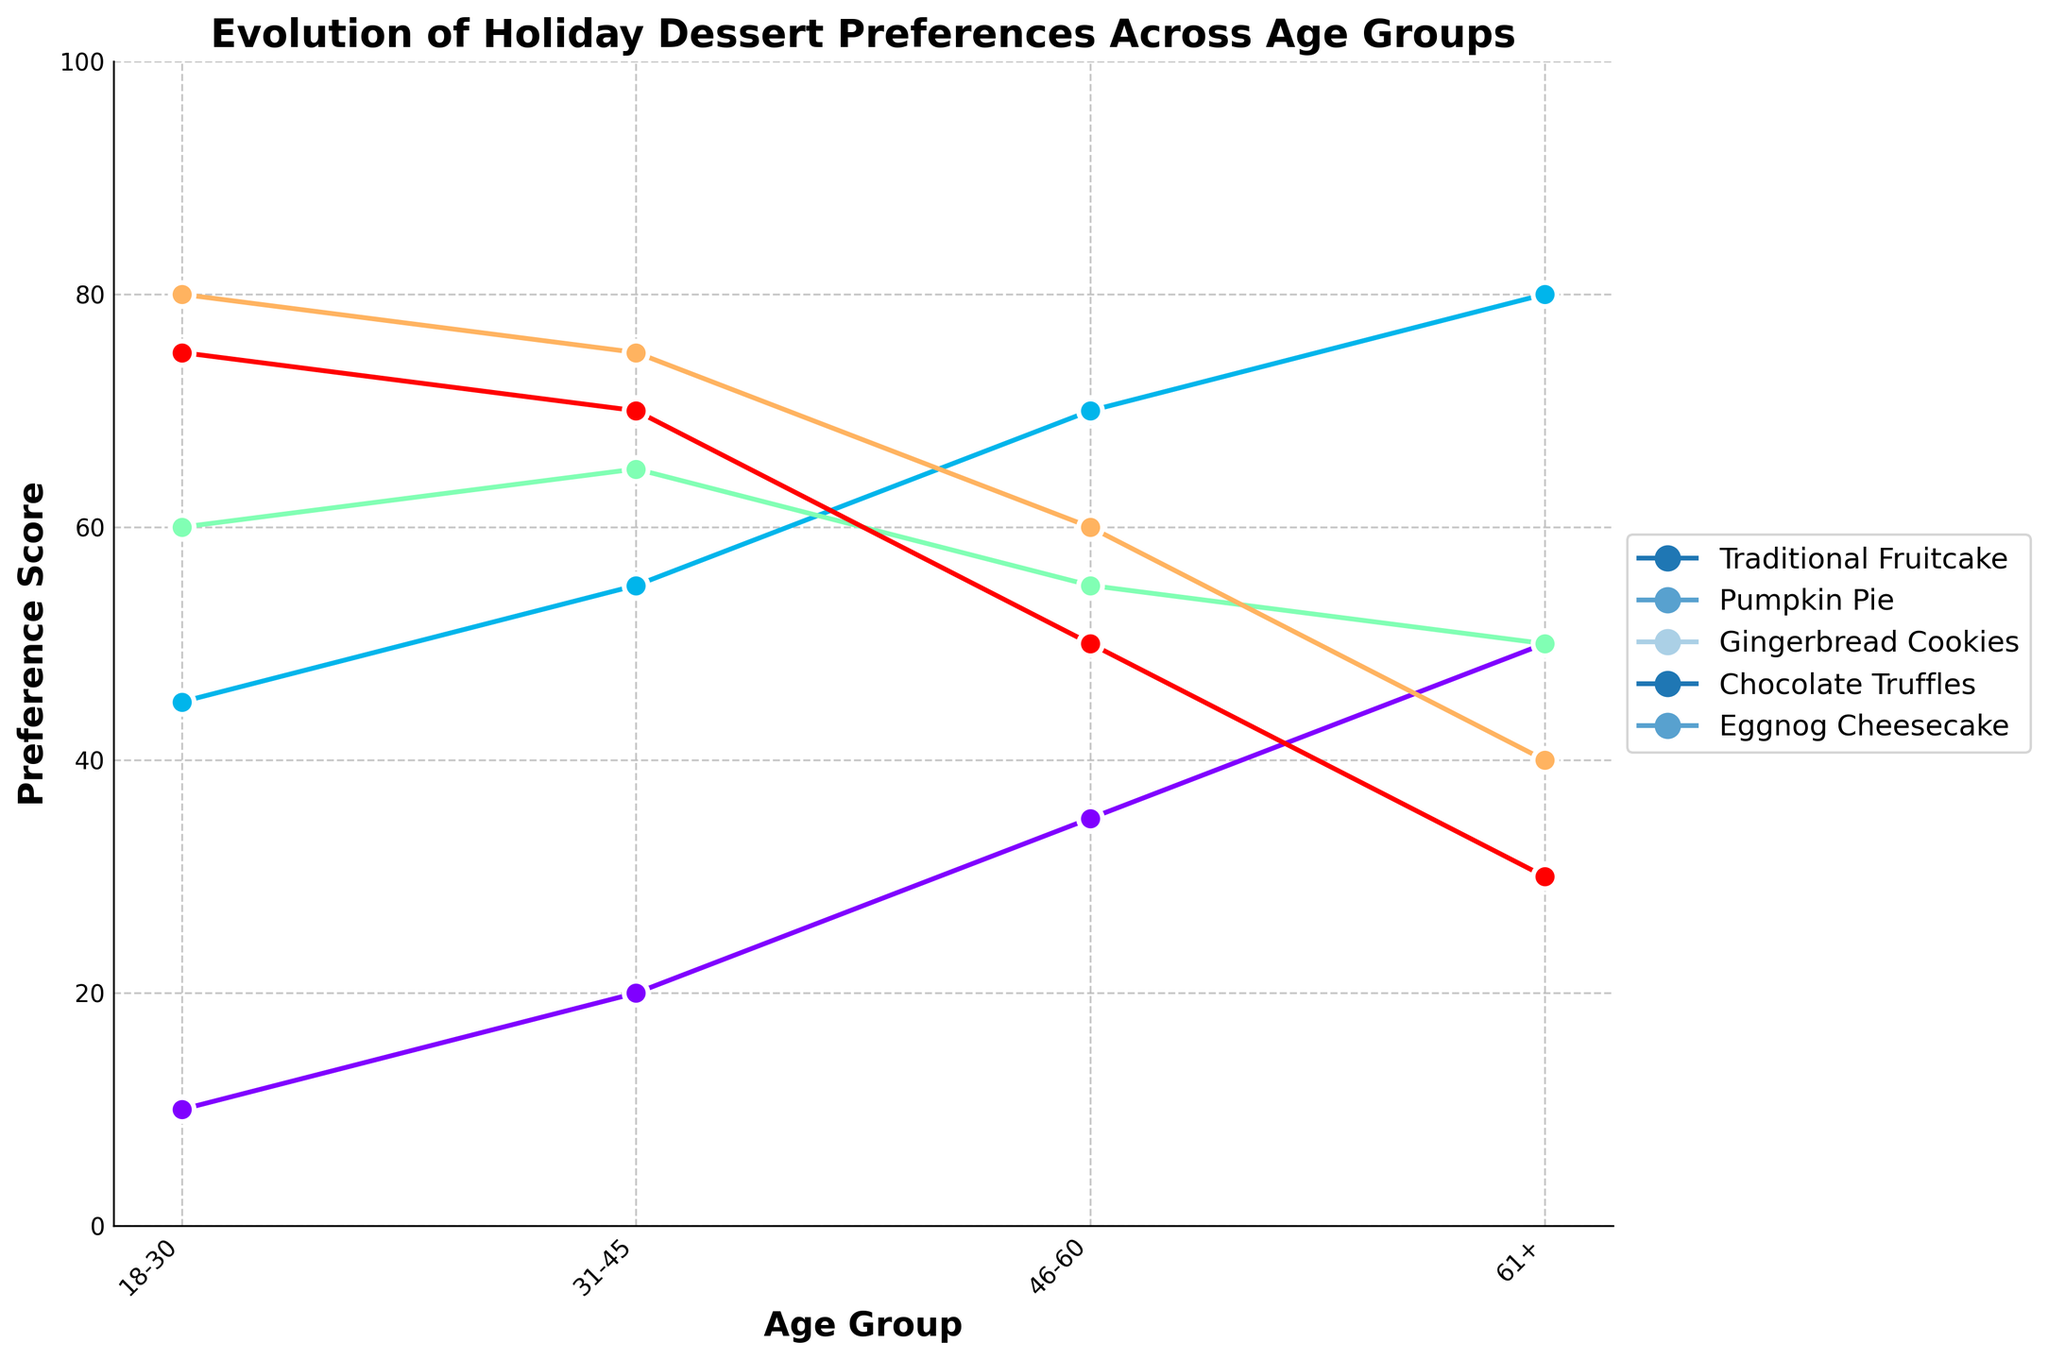What age group has the highest preference for Traditional Fruitcake? The line corresponding to Traditional Fruitcake peaks at the 61+ age group.
Answer: 61+ Which dessert has the most significant decrease in preference from the 18-30 age group to the 61+ age group? By comparing the heights of the lines for each dessert, Chocolate Truffles decreases the most from 80 to 40.
Answer: Chocolate Truffles Among the 46-60 age group, which dessert ranks second in preference? For the 46-60 age group, Pumpkin Pie has the highest preference at 70, followed by Traditional Fruitcake at 35.
Answer: Traditional Fruitcake What is the average preference score for Eggnog Cheesecake across all age groups? The preference scores for Eggnog Cheesecake across all age groups are 75, 70, 50, 30. The average is (75 + 70 + 50 + 30) / 4 = 56.25.
Answer: 56.25 Which age group shows a higher preference for Gingerbread Cookies compared to Pumpkin Pie? The 18-30 age group shows preferences of 60 for Gingerbread Cookies and 45 for Pumpkin Pie, which means higher preference for Gingerbread Cookies.
Answer: 18-30 How does the preference for Chocolate Truffles change from the 31-45 age group to the 46-60 age group? The preference score decreases from 75 in the 31-45 age group to 60 in the 46-60 age group, showing a decrease.
Answer: Decreases How many desserts have a higher preference score in the 31-45 age group compared to the 46-60 age group? Comparing the scores, Pumpkin Pie and Gingerbread Cookies have higher scores in the 31-45 age group compared to the 46-60 age group.
Answer: 2 desserts What is the combined preference score for Pumpkin Pie and Gingerbread Cookies in the 46-60 age group? The scores for Pumpkin Pie and Gingerbread Cookies in the 46-60 age group are 70 and 55 respectively. Combined, they are 70 + 55 = 125.
Answer: 125 